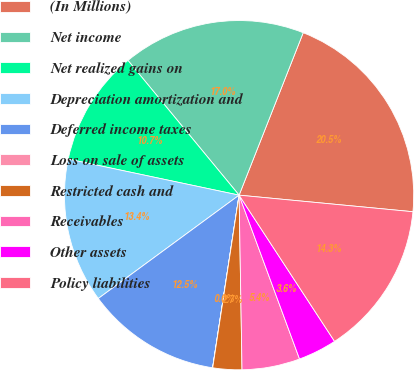<chart> <loc_0><loc_0><loc_500><loc_500><pie_chart><fcel>(In Millions)<fcel>Net income<fcel>Net realized gains on<fcel>Depreciation amortization and<fcel>Deferred income taxes<fcel>Loss on sale of assets<fcel>Restricted cash and<fcel>Receivables<fcel>Other assets<fcel>Policy liabilities<nl><fcel>20.53%<fcel>16.96%<fcel>10.71%<fcel>13.39%<fcel>12.5%<fcel>0.01%<fcel>2.68%<fcel>5.36%<fcel>3.58%<fcel>14.28%<nl></chart> 